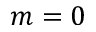<formula> <loc_0><loc_0><loc_500><loc_500>m = 0</formula> 